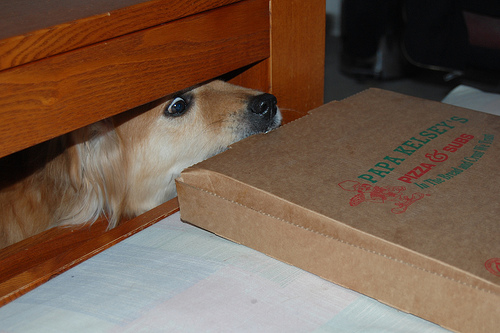<image>
Is there a dog under the wood? Yes. The dog is positioned underneath the wood, with the wood above it in the vertical space. 